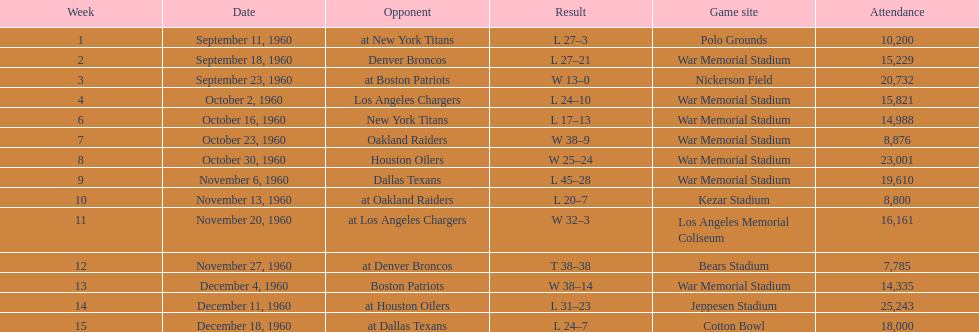After their match with the oakland raiders, who were the bills up against? Houston Oilers. 